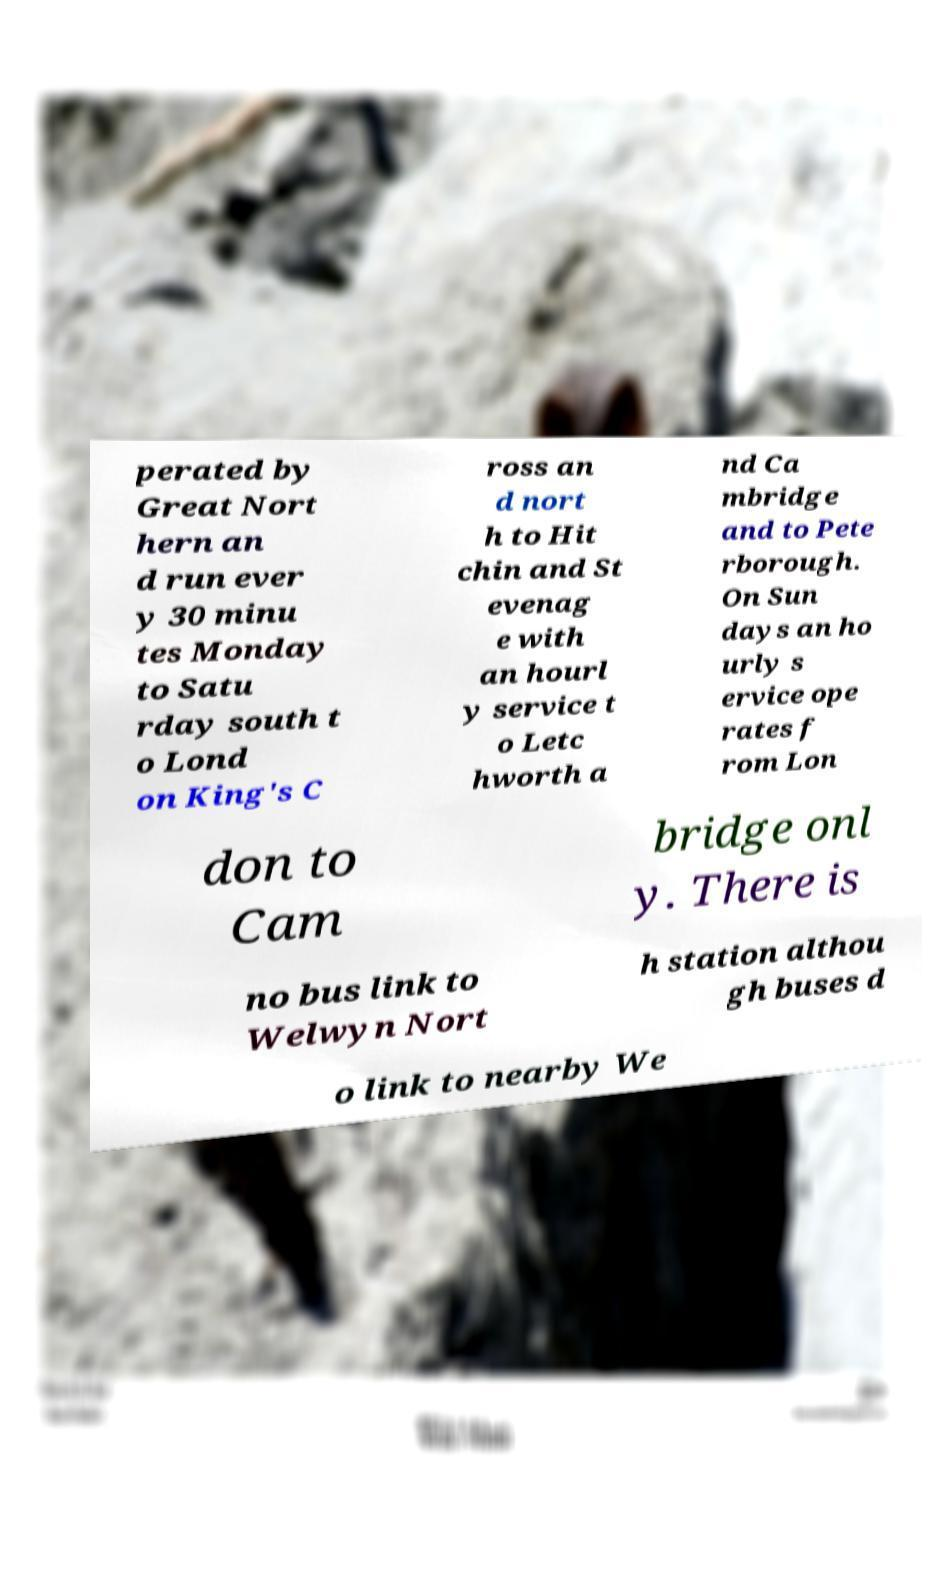Could you assist in decoding the text presented in this image and type it out clearly? perated by Great Nort hern an d run ever y 30 minu tes Monday to Satu rday south t o Lond on King's C ross an d nort h to Hit chin and St evenag e with an hourl y service t o Letc hworth a nd Ca mbridge and to Pete rborough. On Sun days an ho urly s ervice ope rates f rom Lon don to Cam bridge onl y. There is no bus link to Welwyn Nort h station althou gh buses d o link to nearby We 